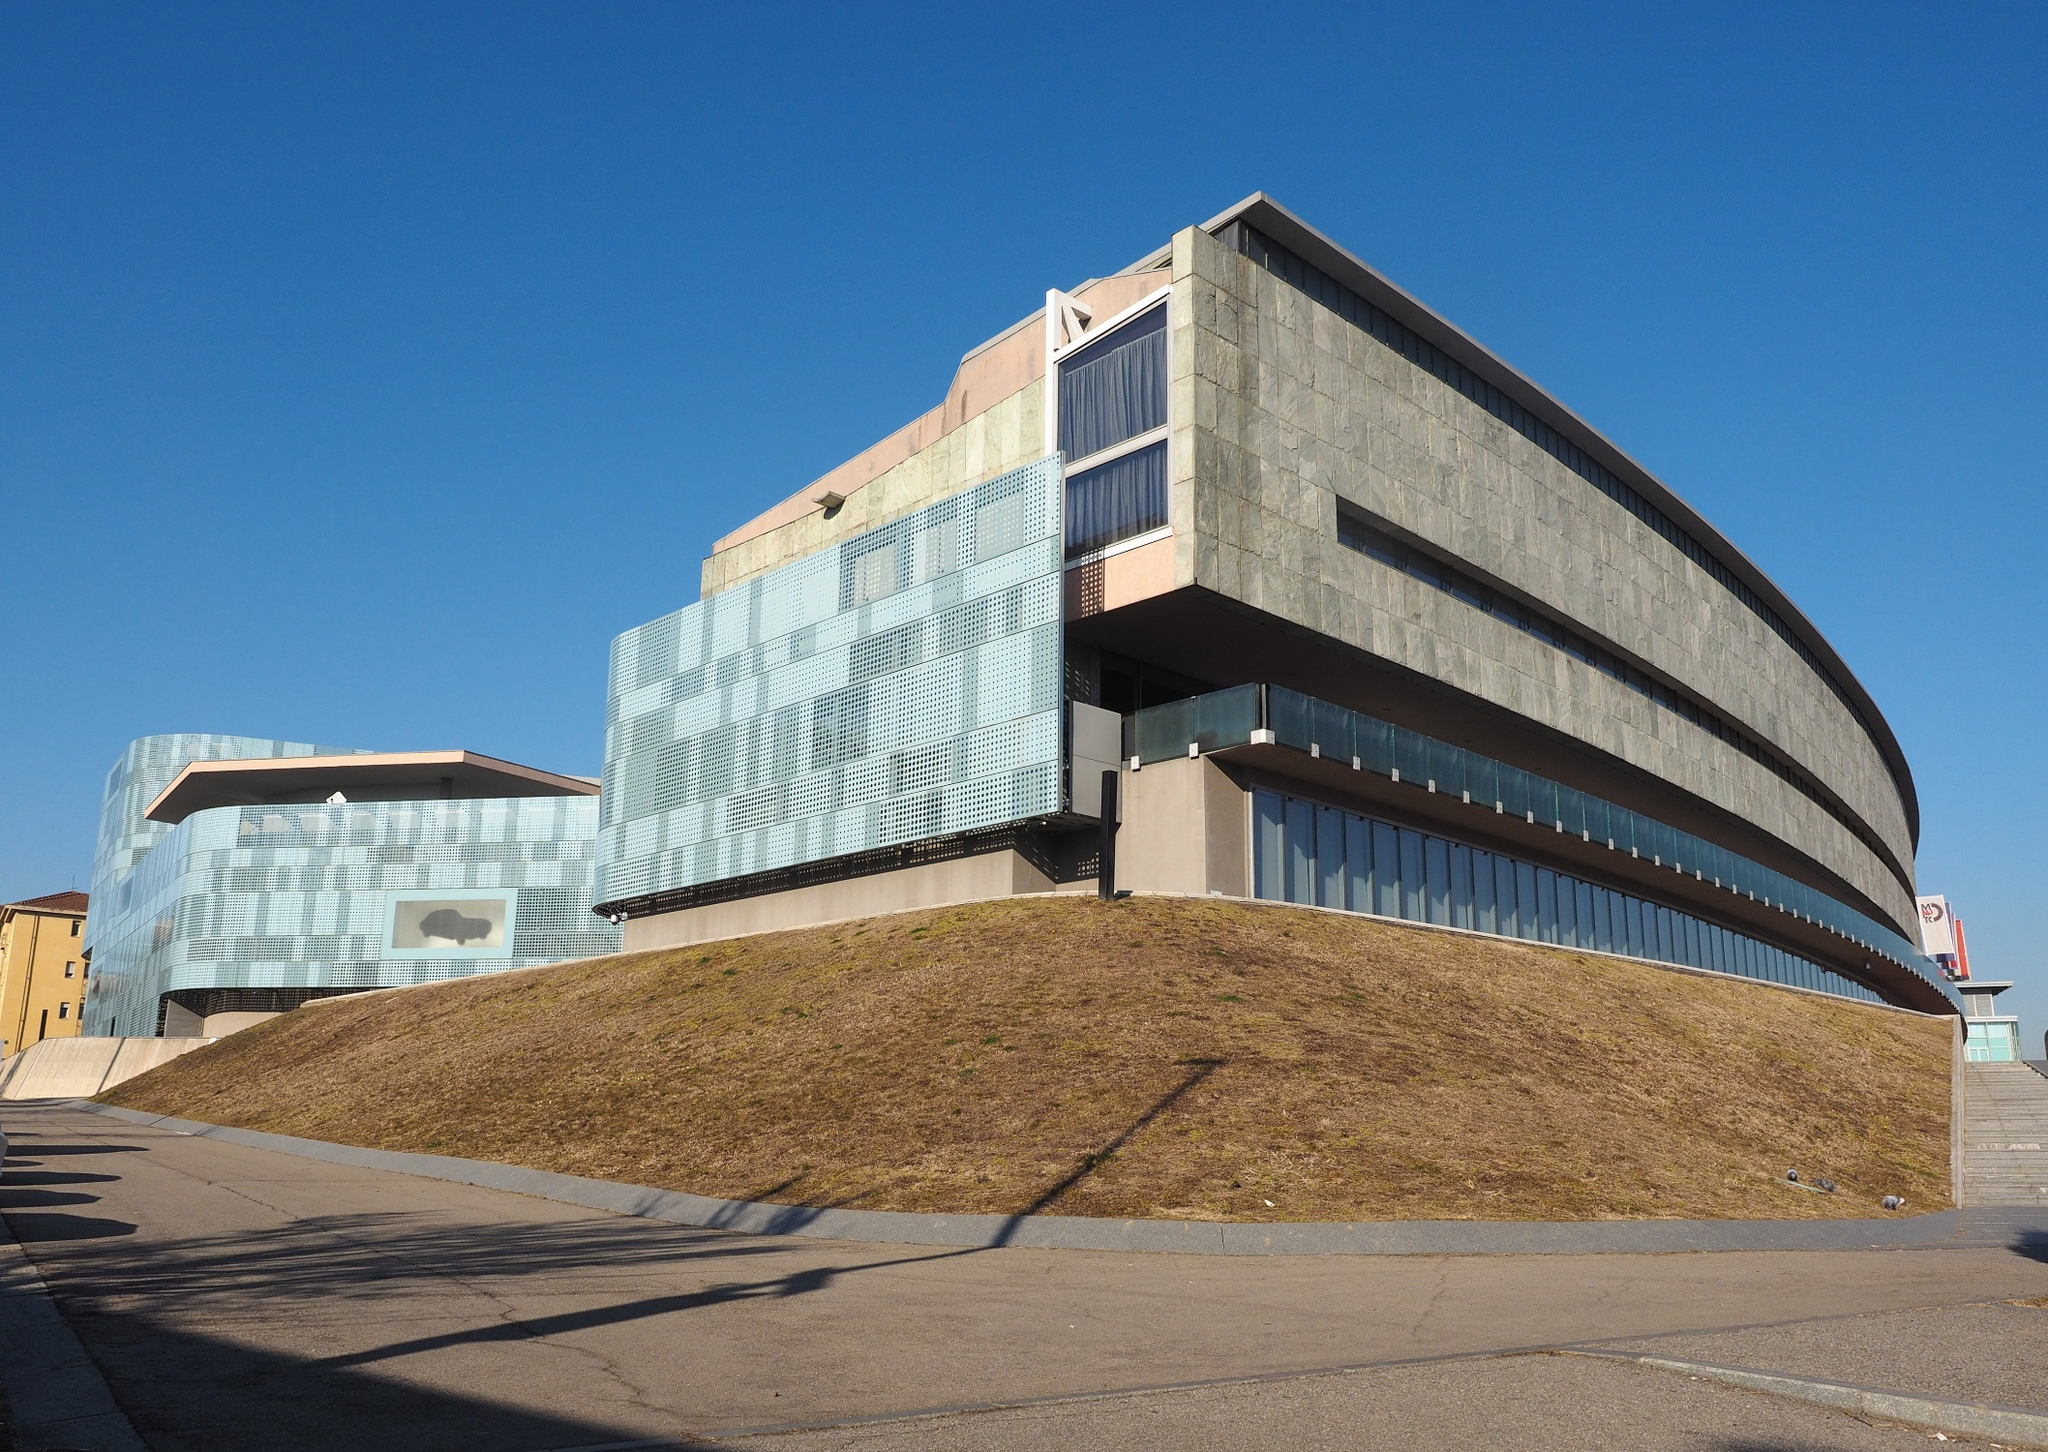What are the key elements in this picture? The image depicts a distinctively modern building characterized by a mix of curved and angular shapes that contribute to a unique architectural silhouette. The structure's facades are predominantly clad in glass and concrete, reflecting hues of gray and blue, complemented by subtle touches of orange and pink. The building is prominently positioned on a grass-covered hill, emphasizing its stature and the innovative use of landscaping to integrate it into the surrounding environment. This architectural piece likely serves a significant public or cultural function, given its design and scale. 